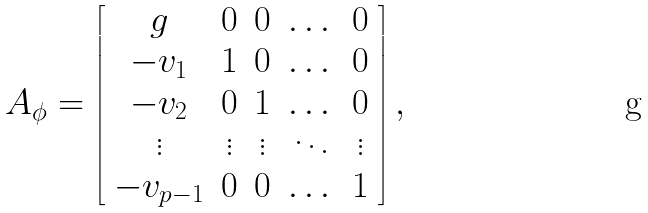<formula> <loc_0><loc_0><loc_500><loc_500>A _ { \phi } = \left [ \begin{array} { c c c c c } g & 0 & 0 & \dots & 0 \\ - v _ { 1 } & 1 & 0 & \dots & 0 \\ - v _ { 2 } & 0 & 1 & \dots & 0 \\ \vdots & \vdots & \vdots & \ddots & \vdots \\ - v _ { p - 1 } & 0 & 0 & \dots & 1 \end{array} \right ] ,</formula> 